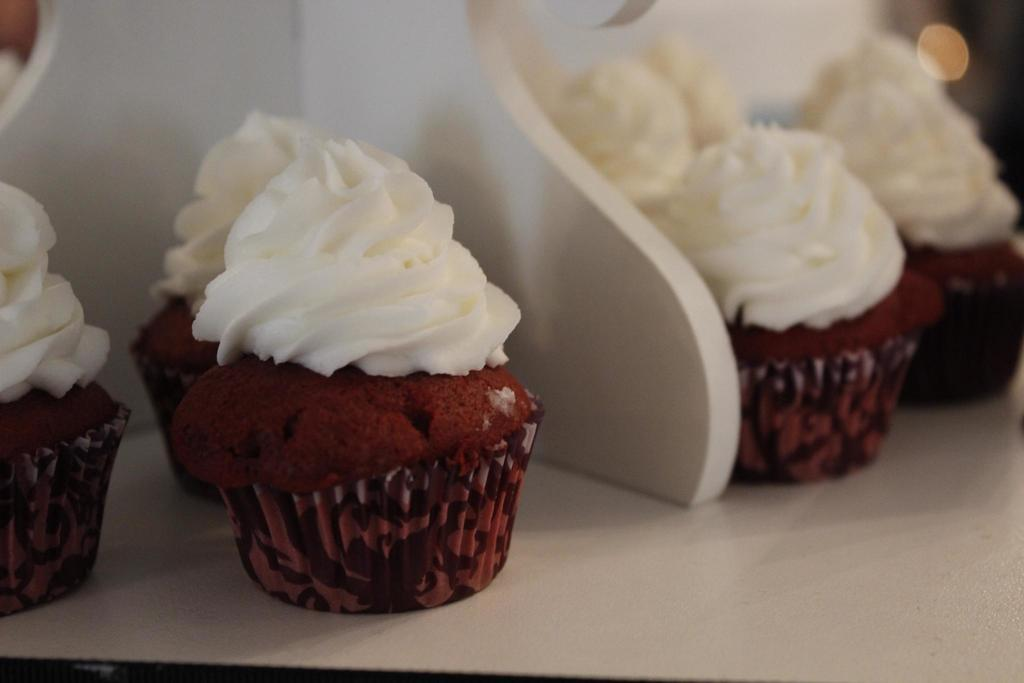What type of food is visible in the image? There are cupcakes in the image. What type of police assistance is required in the image? There is no police presence or assistance required in the image, as it only features cupcakes. 